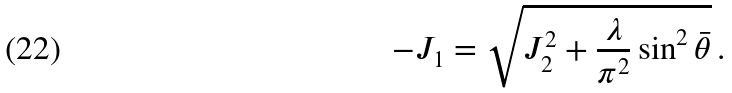Convert formula to latex. <formula><loc_0><loc_0><loc_500><loc_500>- J _ { 1 } = \sqrt { J _ { 2 } ^ { 2 } + \frac { \lambda } { \pi ^ { 2 } } \sin ^ { 2 } \bar { \theta } } \, .</formula> 